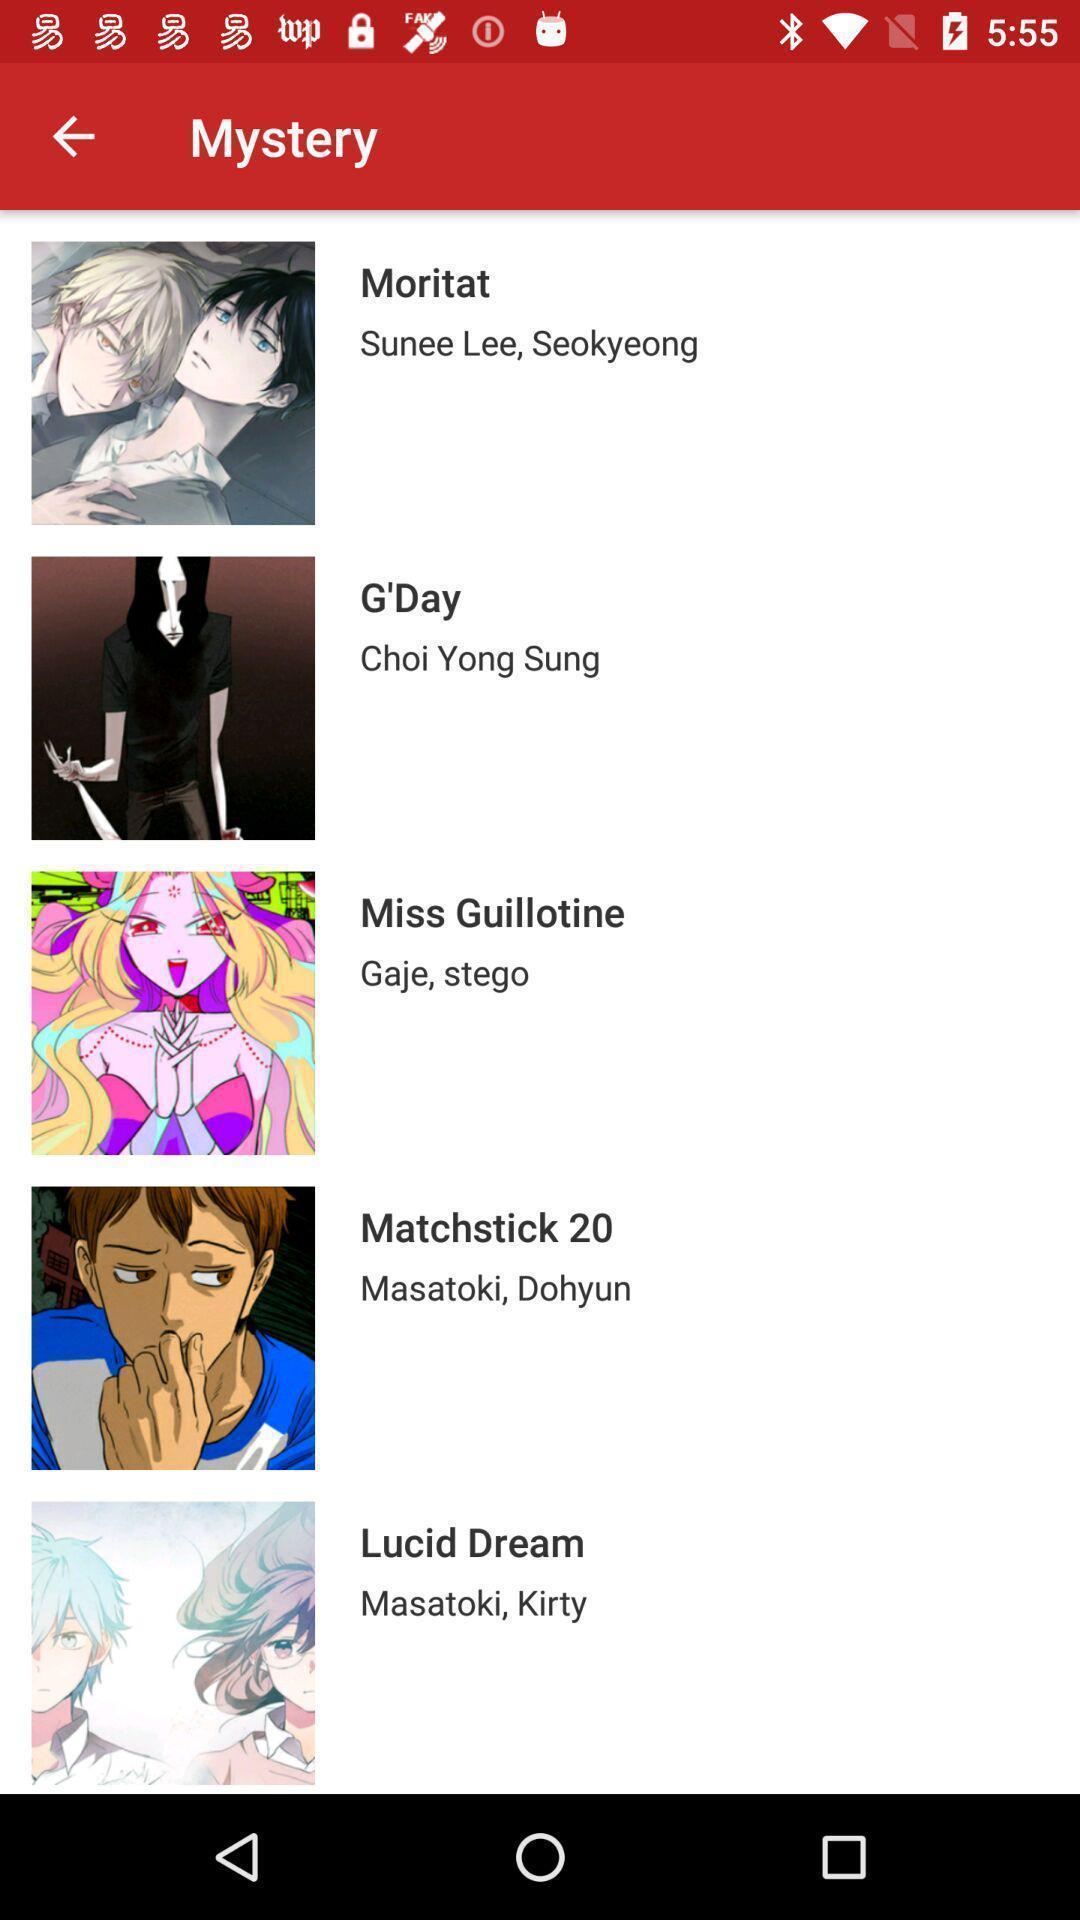Provide a textual representation of this image. Page displaying with list of amines to watch. 